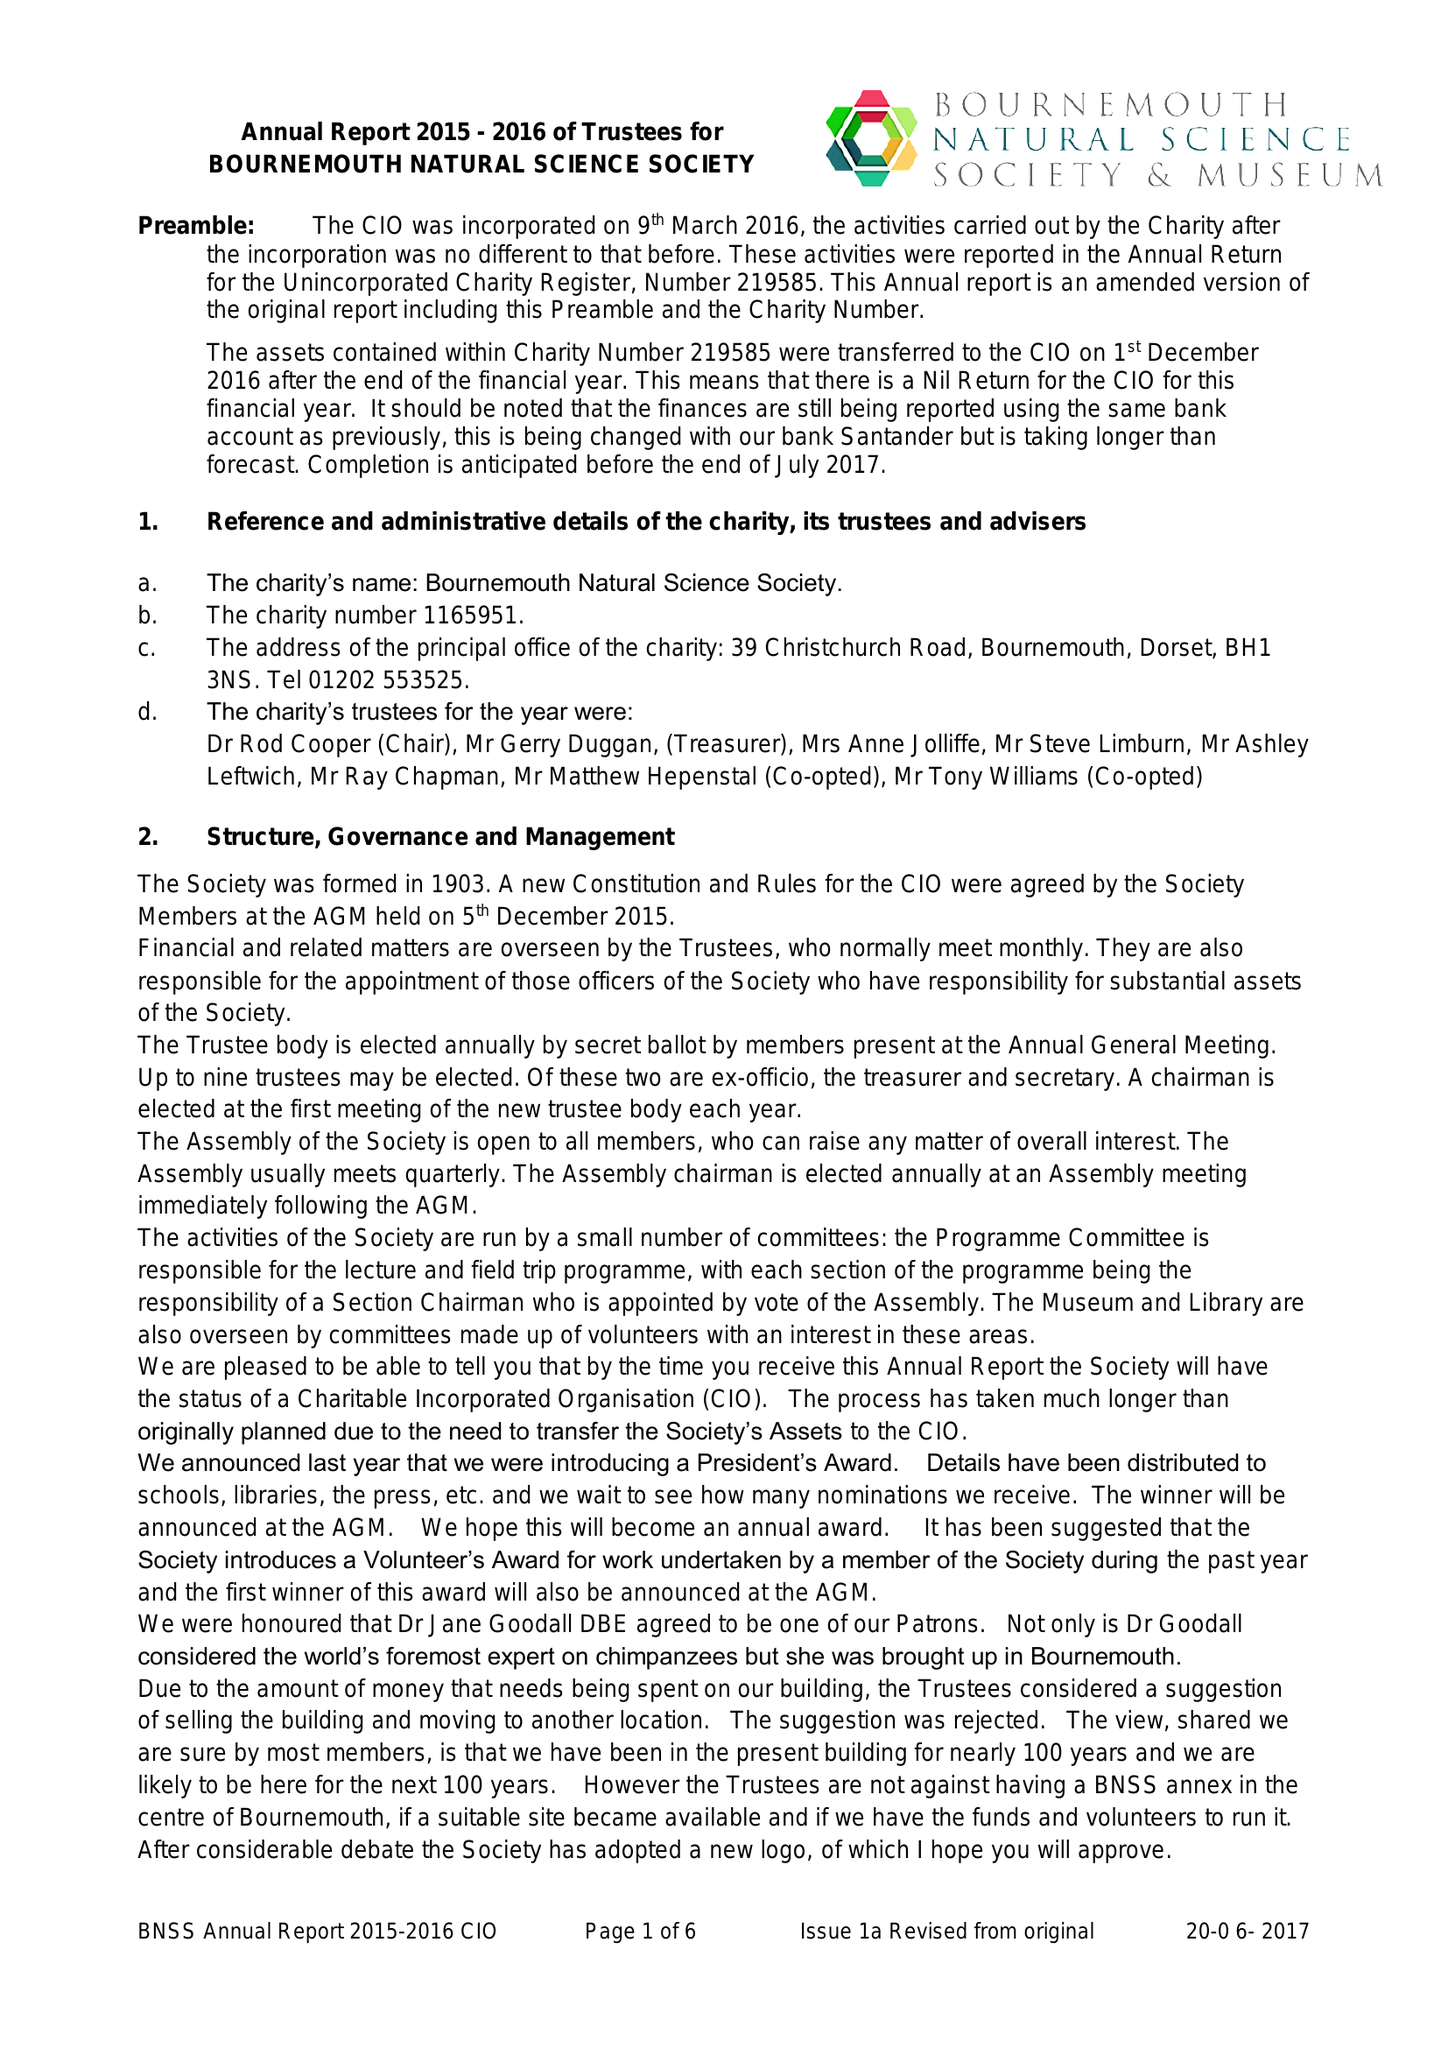What is the value for the address__post_town?
Answer the question using a single word or phrase. BOURNEMOUTH 